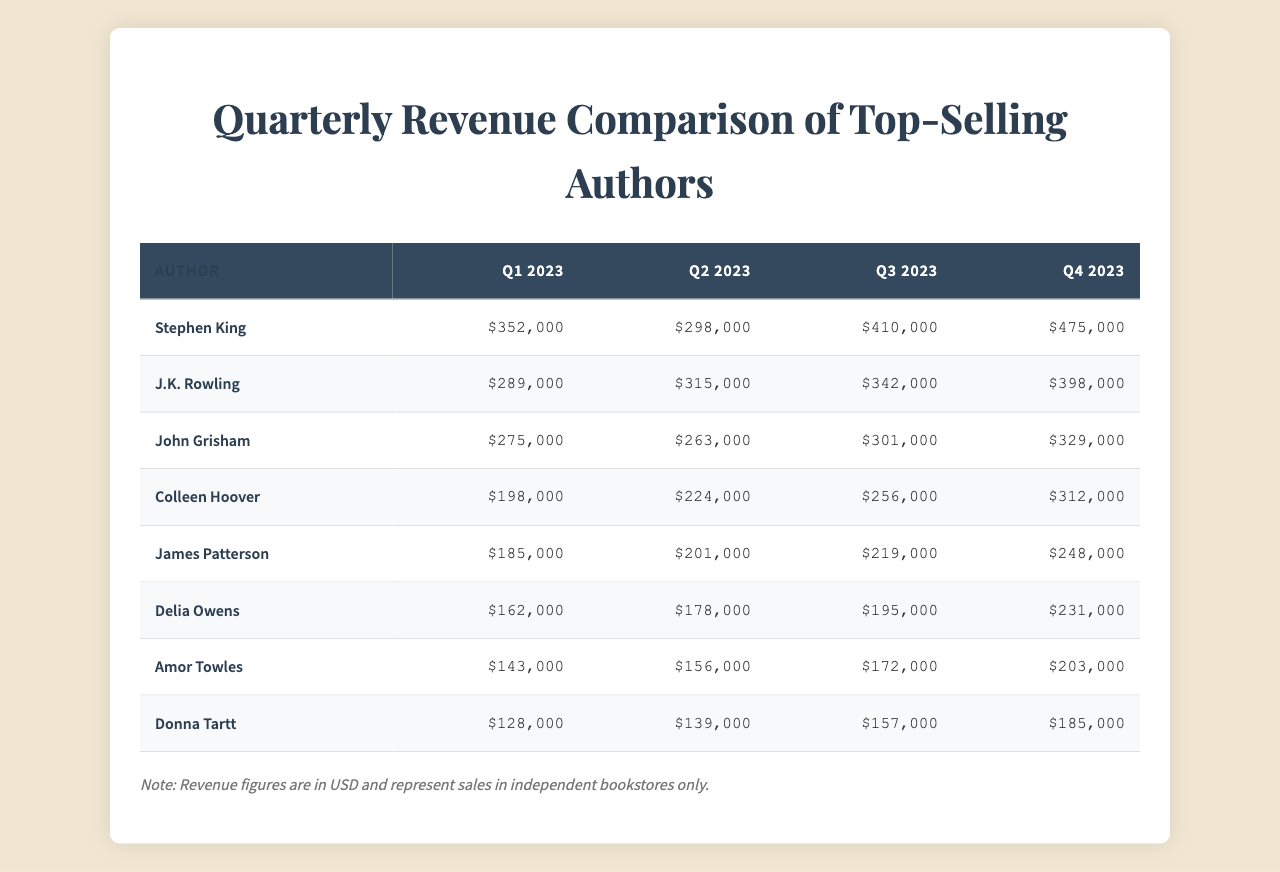What was the revenue of J.K. Rowling in Q3 2023? In the table, I look for J.K. Rowling in the authors column. Her revenue in Q3 2023 is in the column for that quarter, which shows $342,000.
Answer: $342,000 Which author had the highest total revenue across all quarters? I first sum the revenues for each author: Stephen King ($1,535,000), J.K. Rowling ($1,344,000), John Grisham ($1,168,000), Colleen Hoover ($990,000), James Patterson ($853,000), Delia Owens ($766,000), Amor Towles ($674,000), and Donna Tartt ($609,000). The highest is Stephen King with $1,535,000.
Answer: Stephen King What was the revenue difference between Colleen Hoover's Q4 2023 and Q1 2023? Colleen Hoover's revenue in Q4 2023 is $312,000 and in Q1 2023 is $198,000. The difference is $312,000 - $198,000 = $114,000.
Answer: $114,000 Did John Grisham's revenue increase or decrease from Q1 2023 to Q4 2023? In Q1 2023, John Grisham's revenue was $275,000, and in Q4 2023, it was $329,000. Since $329,000 is greater than $275,000, it increased.
Answer: Yes What is the average revenue for James Patterson across all quarters? I sum his revenues: $185,000 + $201,000 + $219,000 + $248,000 = $853,000. There are 4 quarters, so the average is $853,000 / 4 = $213,250.
Answer: $213,250 Which quarter had the lowest total revenue across all authors? To find this, I sum revenues for each quarter: Q1 $1,724,000, Q2 $1,649,000, Q3 $1,799,000, Q4 $1,751,000. The lowest total is for Q2 with $1,649,000.
Answer: Q2 2023 How much more revenue did Delia Owens make in Q4 2023 compared to Q2 2023? Delia Owens made $231,000 in Q4 2023 and $178,000 in Q2 2023. The difference is $231,000 - $178,000 = $53,000.
Answer: $53,000 Which author had the most consistent revenue across all four quarters? I assess the variability in each author's revenues. John Grisham has revenues ranging from $263,000 to $329,000, which is relatively close compared to others. His range is $66,000, indicating consistency.
Answer: John Grisham 